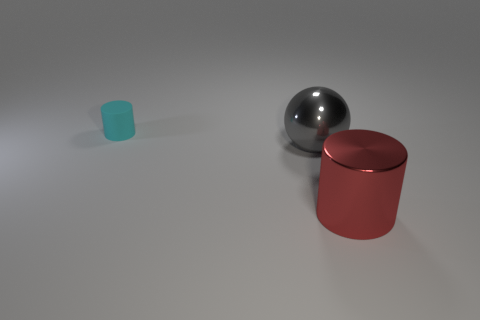Are any large metal spheres visible?
Ensure brevity in your answer.  Yes. Is there a cylinder that has the same material as the gray thing?
Your response must be concise. Yes. Is the number of big balls that are to the right of the large gray object greater than the number of large metallic things behind the red thing?
Ensure brevity in your answer.  No. Do the red cylinder and the cyan cylinder have the same size?
Your answer should be compact. No. There is a shiny thing that is on the right side of the large shiny thing to the left of the red shiny cylinder; what color is it?
Provide a succinct answer. Red. What is the color of the big shiny sphere?
Make the answer very short. Gray. Is there a matte thing that has the same color as the large ball?
Ensure brevity in your answer.  No. There is a cylinder that is to the left of the large shiny cylinder; does it have the same color as the big shiny cylinder?
Offer a terse response. No. What number of objects are big objects behind the big red cylinder or big cyan metallic cubes?
Provide a short and direct response. 1. There is a tiny object; are there any gray objects behind it?
Provide a succinct answer. No. 